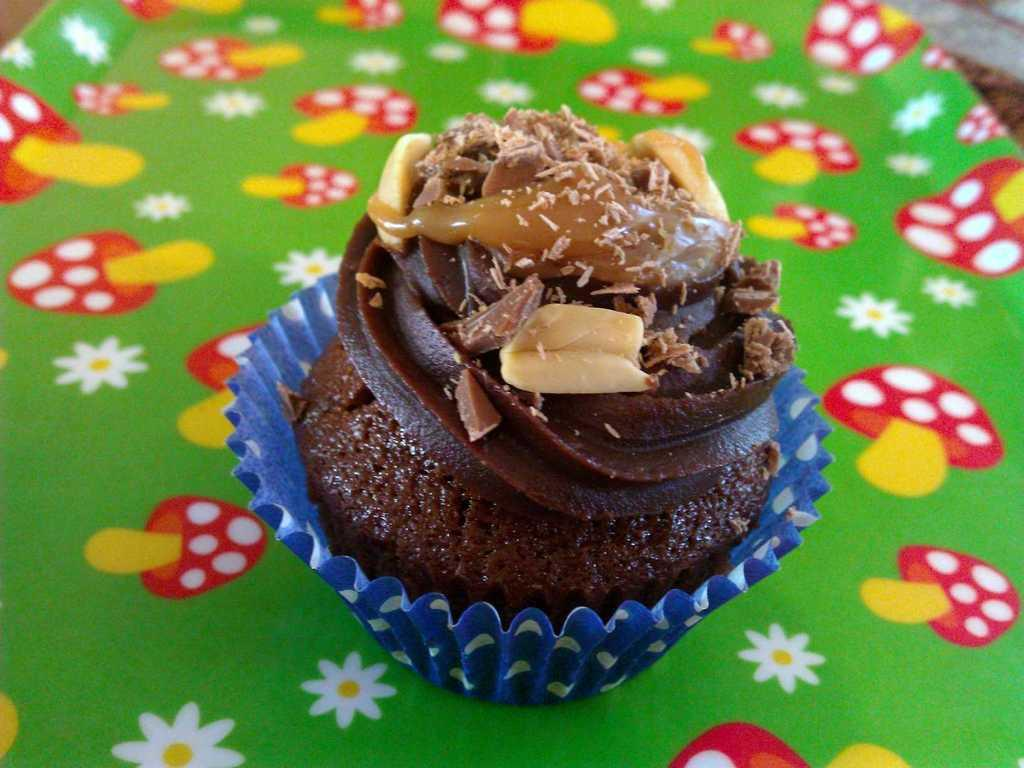What type of dessert is in the image? There is a cupcake in the image. What color is the cupcake? The cupcake is brown in color. What is the cupcake placed on? The cupcake is on a multi-color plate. Can you see a tiger in the image? No, there is no tiger present in the image. What is the elbow's role in the image? There is no mention of an elbow in the image, so it does not have a role in the image. 